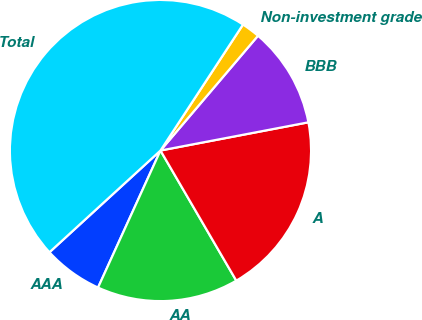Convert chart. <chart><loc_0><loc_0><loc_500><loc_500><pie_chart><fcel>AAA<fcel>AA<fcel>A<fcel>BBB<fcel>Non-investment grade<fcel>Total<nl><fcel>6.39%<fcel>15.2%<fcel>19.6%<fcel>10.79%<fcel>1.98%<fcel>46.03%<nl></chart> 